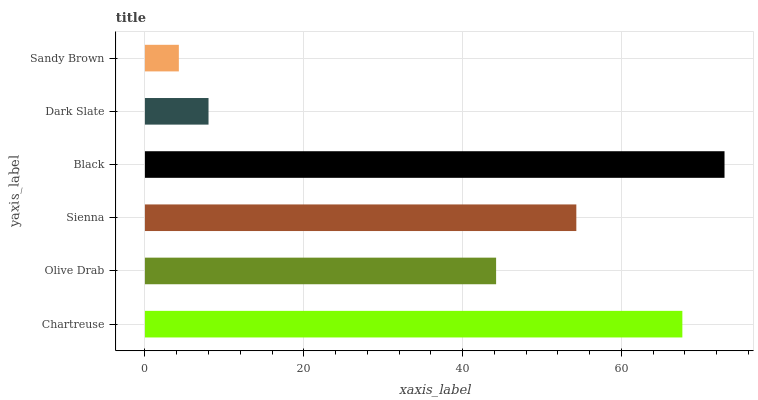Is Sandy Brown the minimum?
Answer yes or no. Yes. Is Black the maximum?
Answer yes or no. Yes. Is Olive Drab the minimum?
Answer yes or no. No. Is Olive Drab the maximum?
Answer yes or no. No. Is Chartreuse greater than Olive Drab?
Answer yes or no. Yes. Is Olive Drab less than Chartreuse?
Answer yes or no. Yes. Is Olive Drab greater than Chartreuse?
Answer yes or no. No. Is Chartreuse less than Olive Drab?
Answer yes or no. No. Is Sienna the high median?
Answer yes or no. Yes. Is Olive Drab the low median?
Answer yes or no. Yes. Is Olive Drab the high median?
Answer yes or no. No. Is Sienna the low median?
Answer yes or no. No. 